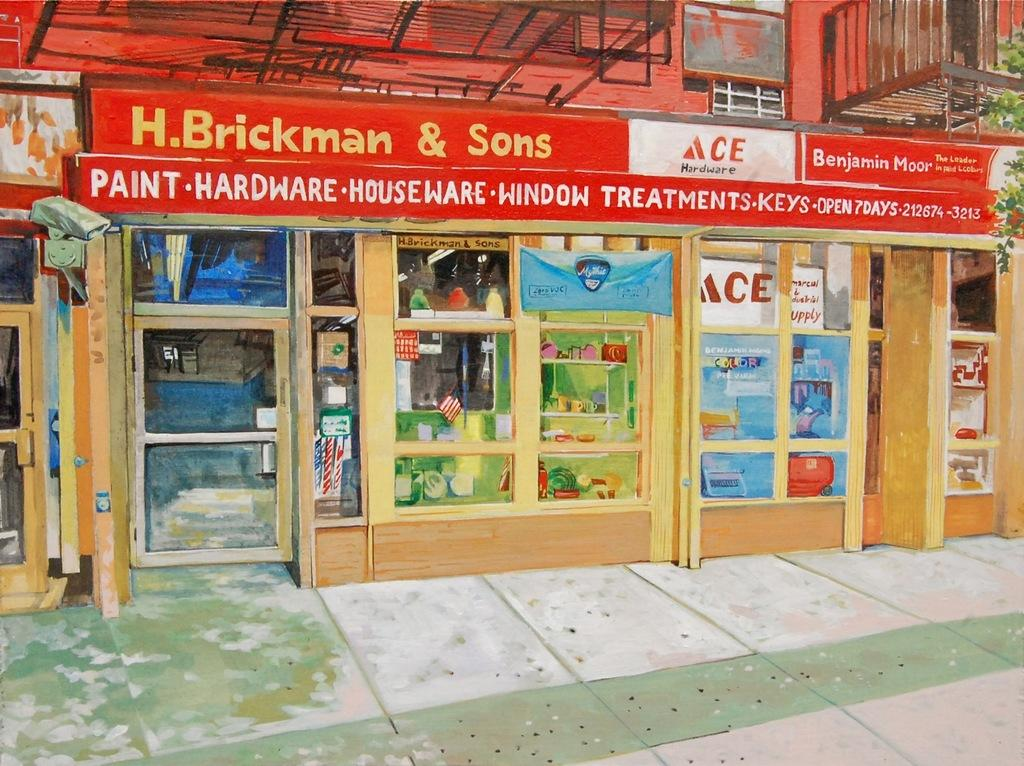<image>
Describe the image concisely. H. Brickman & Sons is a store for hardware, houseware and paint needs. 